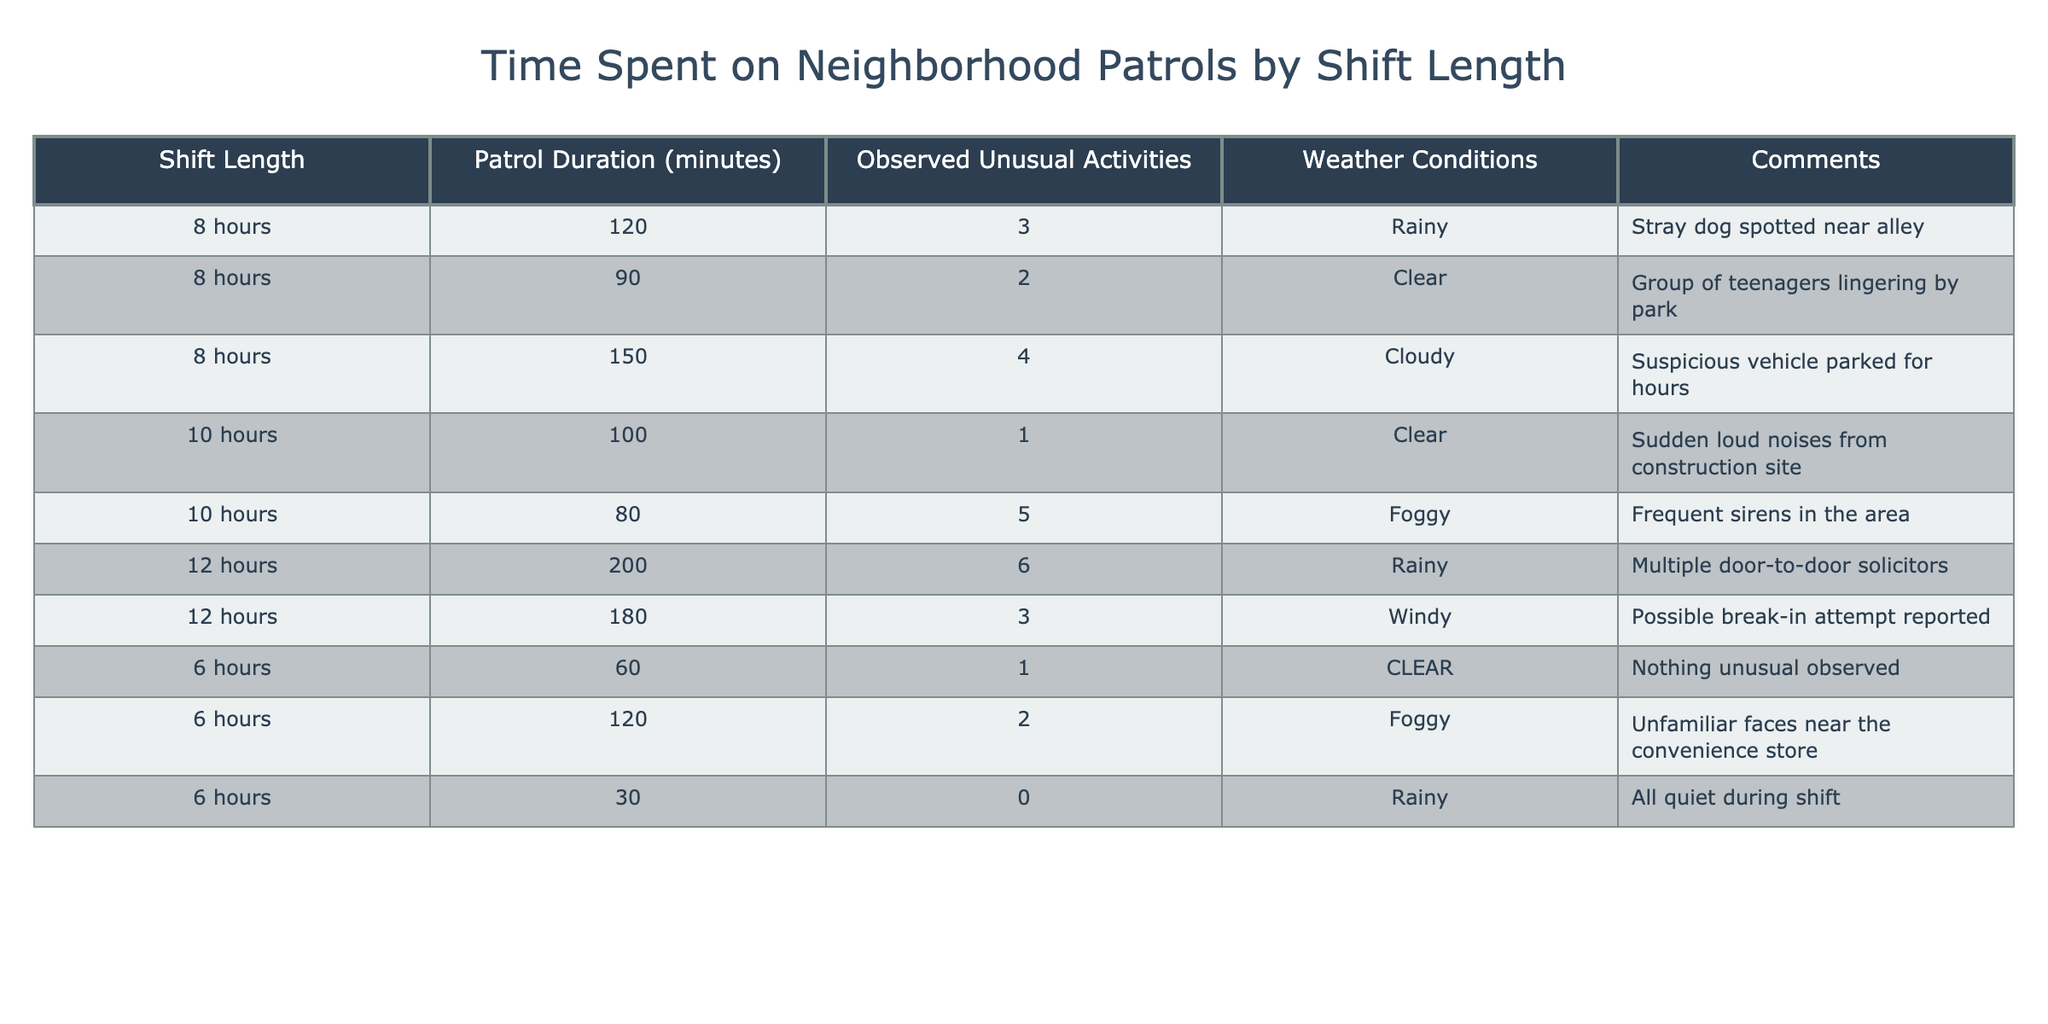What is the patrol duration for a 10-hour shift? In the table, under the 'Patrol Duration (minutes)' column for the 'Shift Length' entry of '10 hours', the corresponding value is 100 minutes for one entry and 80 minutes for another. So, the patrol durations are 100 and 80 minutes.
Answer: 100 and 80 minutes How many unusual activities were observed during the 12-hour shifts? Looking at the entries for '12 hours' under 'Observed Unusual Activities', I can add the values of 6 and 3 together, which gives a total of 9 unusual activities.
Answer: 9 Is there any shift where no unusual activities were observed? Referring to the table, I see that in the entry for a 6-hour shift with a patrol duration of 30 minutes, the value for 'Observed Unusual Activities' is 0. Therefore, the answer is yes.
Answer: Yes What is the average patrol duration across all shifts? To calculate the average patrol duration, I will sum all patrol durations from the table: (120 + 90 + 150 + 100 + 80 + 200 + 180 + 60 + 120 + 30) = 1150 minutes. There are 10 entries, so I divide 1150 by 10, which results in an average of 115 minutes.
Answer: 115 minutes Which weather condition coincided with the highest number of unusual activities? By inspecting the 'Weather Conditions' and 'Observed Unusual Activities' columns, I identify that on the 'Foggy' day there were 5 unusual activities noted during a 10-hour shift and 2 during a 6-hour shift. The maximum observed is 5. Hence, foggy weather had the highest record.
Answer: Foggy What is the total number of unusual activities observed during the 8-hour shifts? To find the total for 8-hour shifts, I check the relevant entries: 3 + 2 + 4 equals 9 unusual activities in total.
Answer: 9 How many comments mention suspicious activity? Looking through the 'Comments' column, entries that include the terms ‘suspicious’ or similar (i.e., suspicious vehicle, possible break-in) indicate suspicious activities. I count 3 relevant entries from the table.
Answer: 3 Was there any unusual activity reported in clear weather? The rows with 'Clear' listed under 'Weather Conditions' have the following unusual activities noted: 2 and 1. Thus, the answer is yes.
Answer: Yes 